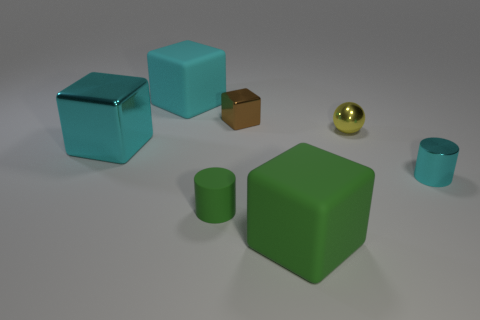There is a large thing that is behind the small yellow thing; what is its shape? The large object behind the small yellow item is a green cube. It has a distinct cubic geometry, characterized by its six square faces, all sides of equal length, and its 90-degree angles. 